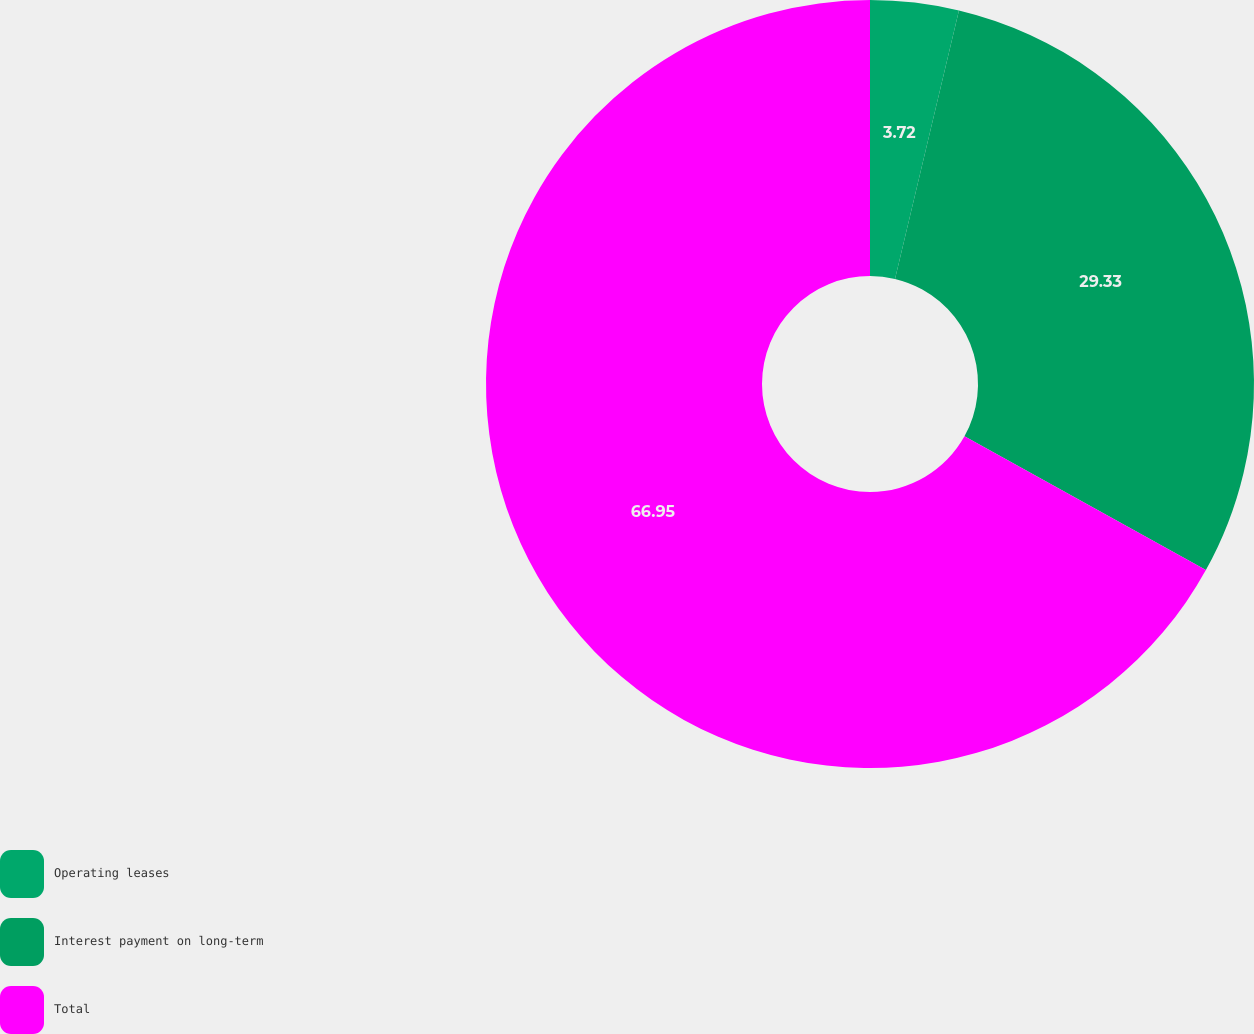Convert chart. <chart><loc_0><loc_0><loc_500><loc_500><pie_chart><fcel>Operating leases<fcel>Interest payment on long-term<fcel>Total<nl><fcel>3.72%<fcel>29.33%<fcel>66.94%<nl></chart> 